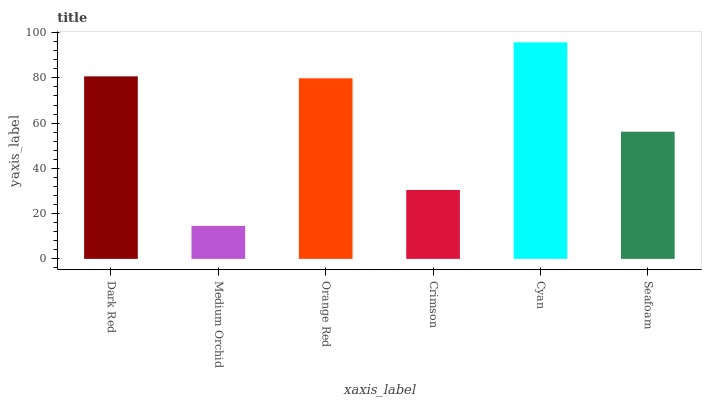Is Medium Orchid the minimum?
Answer yes or no. Yes. Is Cyan the maximum?
Answer yes or no. Yes. Is Orange Red the minimum?
Answer yes or no. No. Is Orange Red the maximum?
Answer yes or no. No. Is Orange Red greater than Medium Orchid?
Answer yes or no. Yes. Is Medium Orchid less than Orange Red?
Answer yes or no. Yes. Is Medium Orchid greater than Orange Red?
Answer yes or no. No. Is Orange Red less than Medium Orchid?
Answer yes or no. No. Is Orange Red the high median?
Answer yes or no. Yes. Is Seafoam the low median?
Answer yes or no. Yes. Is Crimson the high median?
Answer yes or no. No. Is Cyan the low median?
Answer yes or no. No. 